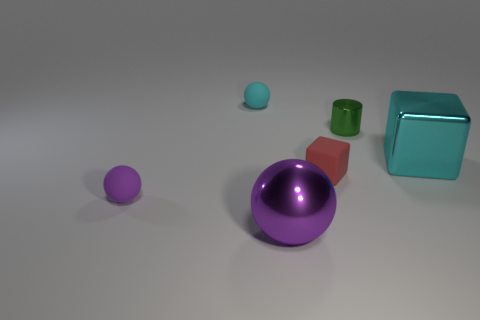Does the large purple object have the same material as the tiny sphere that is to the left of the small cyan rubber sphere?
Your answer should be very brief. No. Are there the same number of green metallic cylinders on the left side of the small red cube and balls that are in front of the small green cylinder?
Ensure brevity in your answer.  No. Is the size of the metal block the same as the rubber thing in front of the tiny red object?
Your answer should be very brief. No. Is the number of metallic things behind the small red cube greater than the number of small green cylinders?
Offer a very short reply. Yes. How many shiny cylinders have the same size as the cyan sphere?
Your answer should be compact. 1. There is a rubber ball that is behind the big cyan thing; is its size the same as the matte sphere that is in front of the large metallic cube?
Make the answer very short. Yes. Is the number of cyan things that are left of the green cylinder greater than the number of purple things right of the big purple metal sphere?
Your response must be concise. Yes. How many red matte objects have the same shape as the big cyan metallic object?
Your response must be concise. 1. What is the material of the green thing that is the same size as the red rubber object?
Provide a short and direct response. Metal. Is there a tiny green cylinder that has the same material as the large cyan cube?
Your answer should be compact. Yes. 